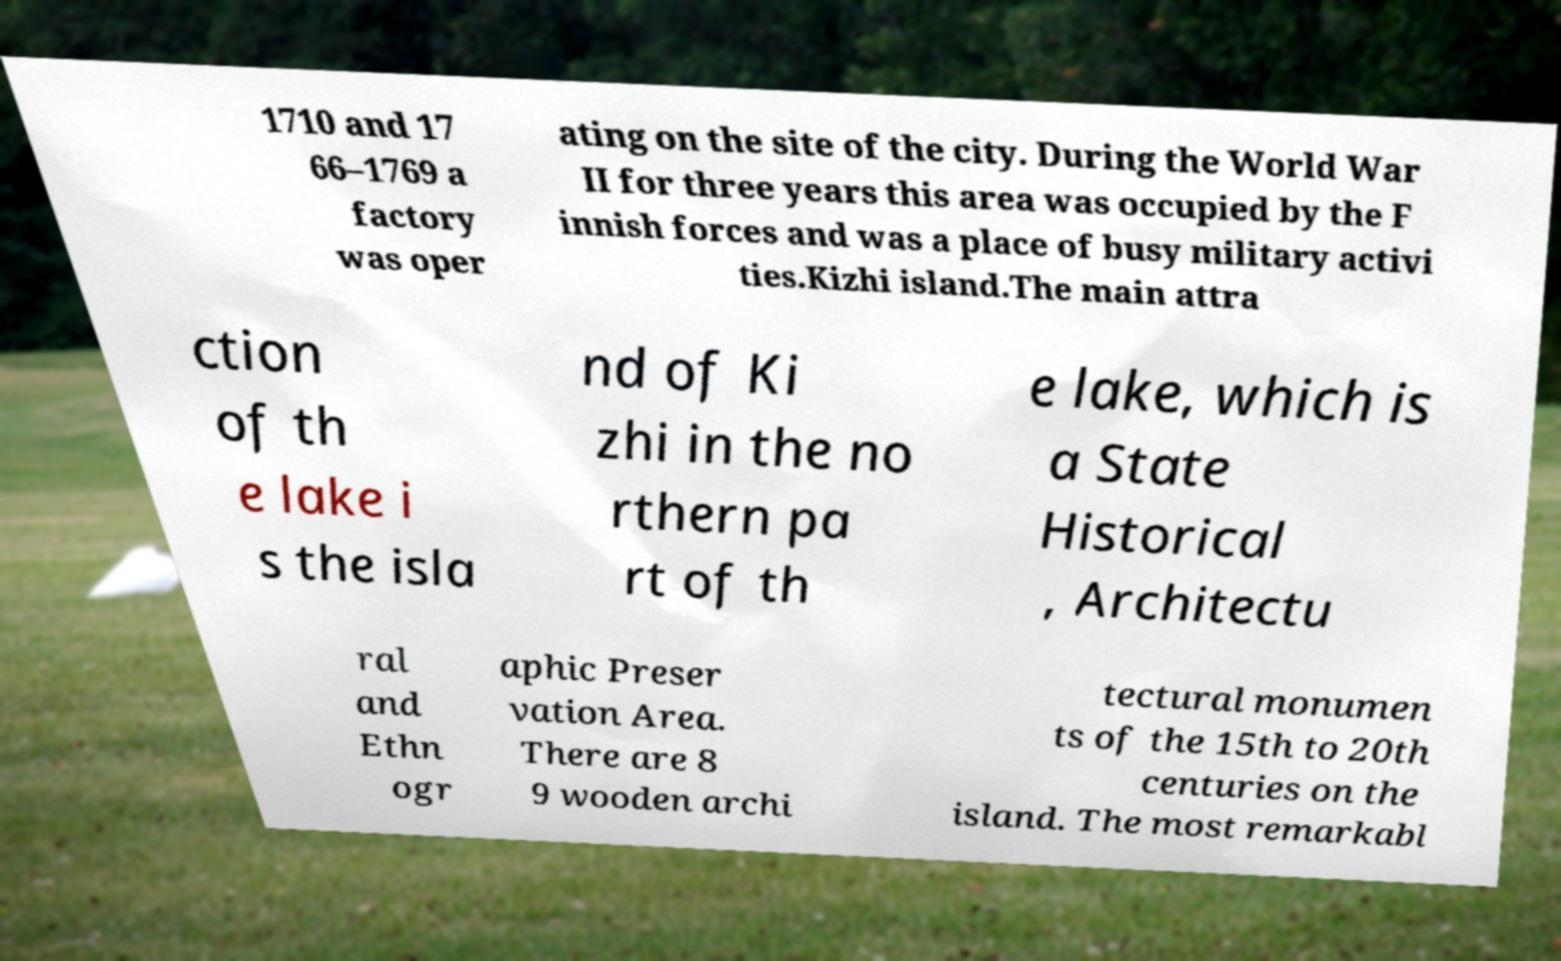What messages or text are displayed in this image? I need them in a readable, typed format. 1710 and 17 66–1769 a factory was oper ating on the site of the city. During the World War II for three years this area was occupied by the F innish forces and was a place of busy military activi ties.Kizhi island.The main attra ction of th e lake i s the isla nd of Ki zhi in the no rthern pa rt of th e lake, which is a State Historical , Architectu ral and Ethn ogr aphic Preser vation Area. There are 8 9 wooden archi tectural monumen ts of the 15th to 20th centuries on the island. The most remarkabl 